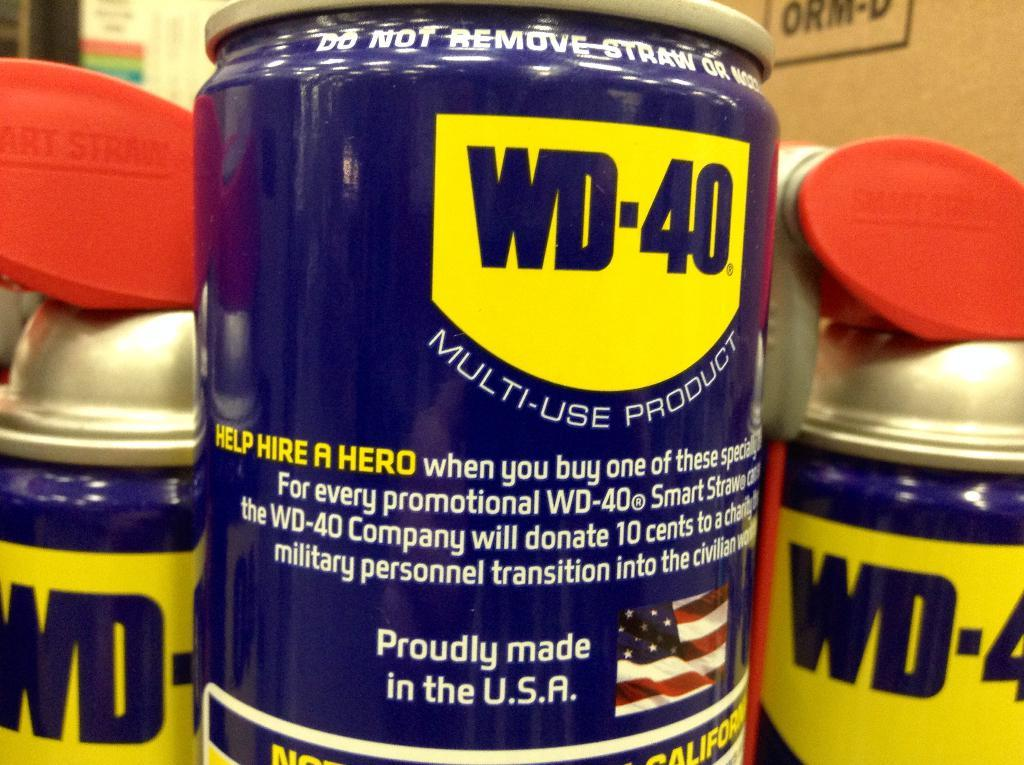<image>
Offer a succinct explanation of the picture presented. several cans of wd-40 multi-use product that is made in the usa 